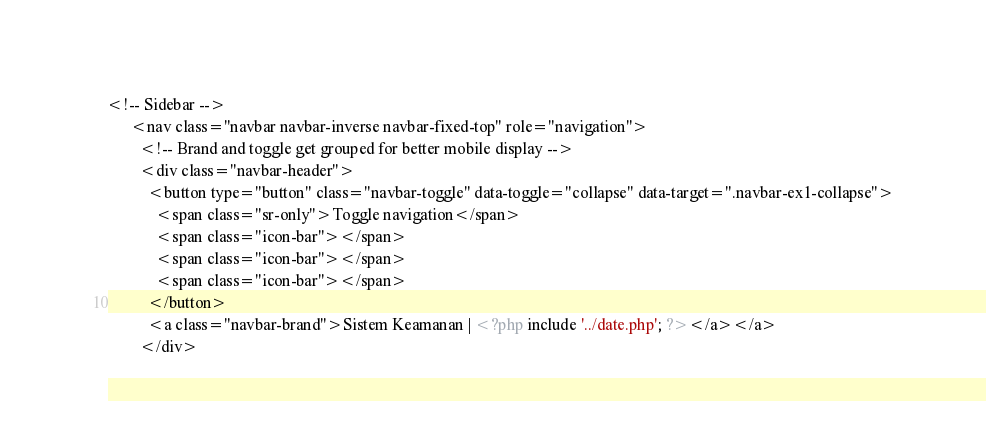<code> <loc_0><loc_0><loc_500><loc_500><_PHP_><!-- Sidebar -->
      <nav class="navbar navbar-inverse navbar-fixed-top" role="navigation">
        <!-- Brand and toggle get grouped for better mobile display -->
        <div class="navbar-header">
          <button type="button" class="navbar-toggle" data-toggle="collapse" data-target=".navbar-ex1-collapse">
            <span class="sr-only">Toggle navigation</span>
            <span class="icon-bar"></span>
            <span class="icon-bar"></span>
            <span class="icon-bar"></span>
          </button>
          <a class="navbar-brand">Sistem Keamanan | <?php include '../date.php'; ?></a></a>
        </div>
</code> 